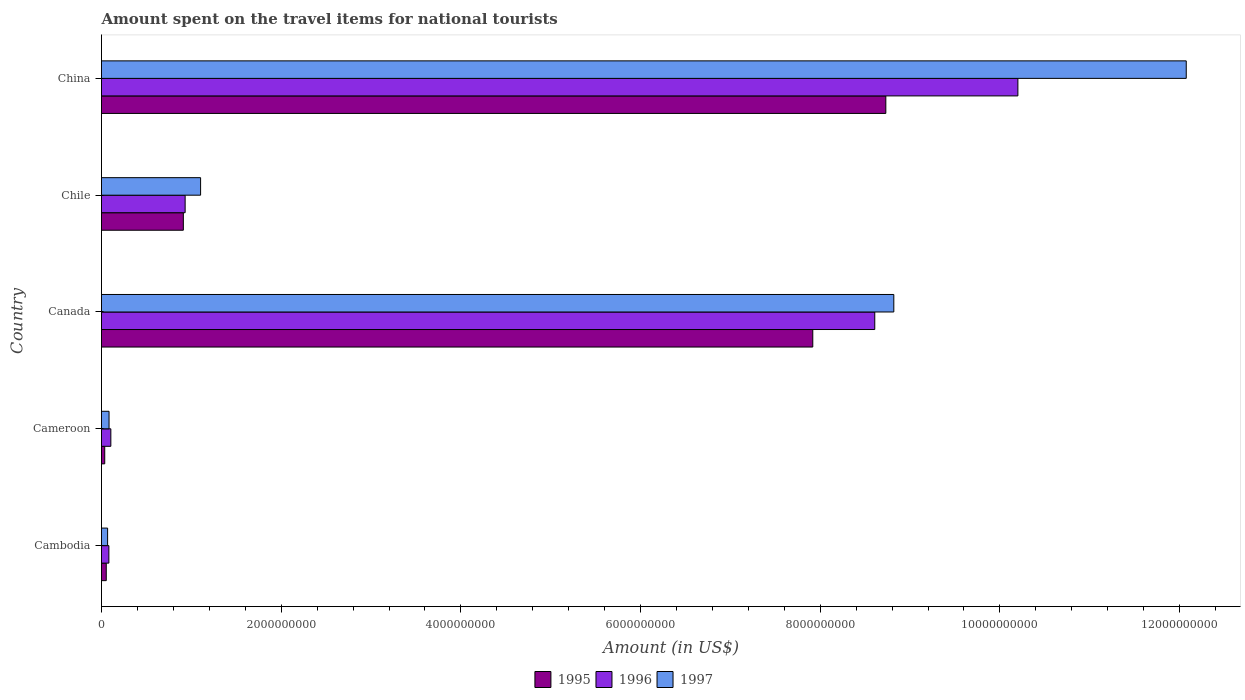How many different coloured bars are there?
Keep it short and to the point. 3. Are the number of bars per tick equal to the number of legend labels?
Make the answer very short. Yes. Are the number of bars on each tick of the Y-axis equal?
Provide a succinct answer. Yes. What is the label of the 3rd group of bars from the top?
Offer a terse response. Canada. What is the amount spent on the travel items for national tourists in 1997 in Cameroon?
Your answer should be very brief. 8.40e+07. Across all countries, what is the maximum amount spent on the travel items for national tourists in 1997?
Your answer should be very brief. 1.21e+1. Across all countries, what is the minimum amount spent on the travel items for national tourists in 1995?
Offer a terse response. 3.60e+07. In which country was the amount spent on the travel items for national tourists in 1996 maximum?
Keep it short and to the point. China. In which country was the amount spent on the travel items for national tourists in 1997 minimum?
Make the answer very short. Cambodia. What is the total amount spent on the travel items for national tourists in 1996 in the graph?
Keep it short and to the point. 1.99e+1. What is the difference between the amount spent on the travel items for national tourists in 1997 in Cambodia and that in Cameroon?
Your answer should be compact. -1.60e+07. What is the difference between the amount spent on the travel items for national tourists in 1996 in Chile and the amount spent on the travel items for national tourists in 1995 in Cambodia?
Your response must be concise. 8.78e+08. What is the average amount spent on the travel items for national tourists in 1995 per country?
Offer a very short reply. 3.53e+09. What is the difference between the amount spent on the travel items for national tourists in 1997 and amount spent on the travel items for national tourists in 1996 in Cameroon?
Your answer should be very brief. -2.00e+07. What is the ratio of the amount spent on the travel items for national tourists in 1997 in Canada to that in China?
Offer a very short reply. 0.73. Is the amount spent on the travel items for national tourists in 1996 in Cameroon less than that in Canada?
Offer a terse response. Yes. Is the difference between the amount spent on the travel items for national tourists in 1997 in Canada and Chile greater than the difference between the amount spent on the travel items for national tourists in 1996 in Canada and Chile?
Give a very brief answer. Yes. What is the difference between the highest and the second highest amount spent on the travel items for national tourists in 1995?
Offer a terse response. 8.13e+08. What is the difference between the highest and the lowest amount spent on the travel items for national tourists in 1995?
Ensure brevity in your answer.  8.69e+09. Is the sum of the amount spent on the travel items for national tourists in 1997 in Chile and China greater than the maximum amount spent on the travel items for national tourists in 1995 across all countries?
Your answer should be very brief. Yes. What does the 2nd bar from the top in China represents?
Keep it short and to the point. 1996. What does the 1st bar from the bottom in Cambodia represents?
Provide a succinct answer. 1995. How many bars are there?
Provide a succinct answer. 15. Are all the bars in the graph horizontal?
Make the answer very short. Yes. How many countries are there in the graph?
Give a very brief answer. 5. Does the graph contain any zero values?
Offer a terse response. No. Does the graph contain grids?
Ensure brevity in your answer.  No. How many legend labels are there?
Ensure brevity in your answer.  3. What is the title of the graph?
Your response must be concise. Amount spent on the travel items for national tourists. What is the Amount (in US$) of 1995 in Cambodia?
Keep it short and to the point. 5.30e+07. What is the Amount (in US$) in 1996 in Cambodia?
Offer a terse response. 8.20e+07. What is the Amount (in US$) of 1997 in Cambodia?
Your response must be concise. 6.80e+07. What is the Amount (in US$) of 1995 in Cameroon?
Your answer should be compact. 3.60e+07. What is the Amount (in US$) in 1996 in Cameroon?
Provide a short and direct response. 1.04e+08. What is the Amount (in US$) in 1997 in Cameroon?
Keep it short and to the point. 8.40e+07. What is the Amount (in US$) in 1995 in Canada?
Your answer should be very brief. 7.92e+09. What is the Amount (in US$) of 1996 in Canada?
Offer a very short reply. 8.61e+09. What is the Amount (in US$) in 1997 in Canada?
Offer a terse response. 8.82e+09. What is the Amount (in US$) of 1995 in Chile?
Your answer should be compact. 9.11e+08. What is the Amount (in US$) in 1996 in Chile?
Offer a very short reply. 9.31e+08. What is the Amount (in US$) of 1997 in Chile?
Your answer should be very brief. 1.10e+09. What is the Amount (in US$) in 1995 in China?
Offer a terse response. 8.73e+09. What is the Amount (in US$) in 1996 in China?
Your answer should be compact. 1.02e+1. What is the Amount (in US$) in 1997 in China?
Ensure brevity in your answer.  1.21e+1. Across all countries, what is the maximum Amount (in US$) of 1995?
Offer a terse response. 8.73e+09. Across all countries, what is the maximum Amount (in US$) of 1996?
Ensure brevity in your answer.  1.02e+1. Across all countries, what is the maximum Amount (in US$) in 1997?
Your answer should be compact. 1.21e+1. Across all countries, what is the minimum Amount (in US$) of 1995?
Your answer should be very brief. 3.60e+07. Across all countries, what is the minimum Amount (in US$) in 1996?
Keep it short and to the point. 8.20e+07. Across all countries, what is the minimum Amount (in US$) in 1997?
Provide a succinct answer. 6.80e+07. What is the total Amount (in US$) of 1995 in the graph?
Give a very brief answer. 1.76e+1. What is the total Amount (in US$) of 1996 in the graph?
Provide a short and direct response. 1.99e+1. What is the total Amount (in US$) in 1997 in the graph?
Make the answer very short. 2.21e+1. What is the difference between the Amount (in US$) in 1995 in Cambodia and that in Cameroon?
Your answer should be very brief. 1.70e+07. What is the difference between the Amount (in US$) of 1996 in Cambodia and that in Cameroon?
Make the answer very short. -2.20e+07. What is the difference between the Amount (in US$) in 1997 in Cambodia and that in Cameroon?
Offer a very short reply. -1.60e+07. What is the difference between the Amount (in US$) in 1995 in Cambodia and that in Canada?
Provide a short and direct response. -7.86e+09. What is the difference between the Amount (in US$) of 1996 in Cambodia and that in Canada?
Offer a terse response. -8.52e+09. What is the difference between the Amount (in US$) of 1997 in Cambodia and that in Canada?
Provide a succinct answer. -8.75e+09. What is the difference between the Amount (in US$) of 1995 in Cambodia and that in Chile?
Ensure brevity in your answer.  -8.58e+08. What is the difference between the Amount (in US$) of 1996 in Cambodia and that in Chile?
Offer a terse response. -8.49e+08. What is the difference between the Amount (in US$) in 1997 in Cambodia and that in Chile?
Offer a terse response. -1.04e+09. What is the difference between the Amount (in US$) of 1995 in Cambodia and that in China?
Offer a very short reply. -8.68e+09. What is the difference between the Amount (in US$) of 1996 in Cambodia and that in China?
Offer a very short reply. -1.01e+1. What is the difference between the Amount (in US$) in 1997 in Cambodia and that in China?
Provide a succinct answer. -1.20e+1. What is the difference between the Amount (in US$) in 1995 in Cameroon and that in Canada?
Keep it short and to the point. -7.88e+09. What is the difference between the Amount (in US$) in 1996 in Cameroon and that in Canada?
Offer a terse response. -8.50e+09. What is the difference between the Amount (in US$) in 1997 in Cameroon and that in Canada?
Your answer should be very brief. -8.74e+09. What is the difference between the Amount (in US$) of 1995 in Cameroon and that in Chile?
Keep it short and to the point. -8.75e+08. What is the difference between the Amount (in US$) in 1996 in Cameroon and that in Chile?
Your response must be concise. -8.27e+08. What is the difference between the Amount (in US$) in 1997 in Cameroon and that in Chile?
Ensure brevity in your answer.  -1.02e+09. What is the difference between the Amount (in US$) of 1995 in Cameroon and that in China?
Your response must be concise. -8.69e+09. What is the difference between the Amount (in US$) of 1996 in Cameroon and that in China?
Ensure brevity in your answer.  -1.01e+1. What is the difference between the Amount (in US$) of 1997 in Cameroon and that in China?
Make the answer very short. -1.20e+1. What is the difference between the Amount (in US$) of 1995 in Canada and that in Chile?
Provide a succinct answer. 7.01e+09. What is the difference between the Amount (in US$) of 1996 in Canada and that in Chile?
Provide a short and direct response. 7.68e+09. What is the difference between the Amount (in US$) of 1997 in Canada and that in Chile?
Provide a succinct answer. 7.72e+09. What is the difference between the Amount (in US$) in 1995 in Canada and that in China?
Give a very brief answer. -8.13e+08. What is the difference between the Amount (in US$) of 1996 in Canada and that in China?
Your answer should be very brief. -1.59e+09. What is the difference between the Amount (in US$) in 1997 in Canada and that in China?
Ensure brevity in your answer.  -3.26e+09. What is the difference between the Amount (in US$) in 1995 in Chile and that in China?
Keep it short and to the point. -7.82e+09. What is the difference between the Amount (in US$) in 1996 in Chile and that in China?
Provide a succinct answer. -9.27e+09. What is the difference between the Amount (in US$) in 1997 in Chile and that in China?
Keep it short and to the point. -1.10e+1. What is the difference between the Amount (in US$) in 1995 in Cambodia and the Amount (in US$) in 1996 in Cameroon?
Provide a short and direct response. -5.10e+07. What is the difference between the Amount (in US$) in 1995 in Cambodia and the Amount (in US$) in 1997 in Cameroon?
Offer a very short reply. -3.10e+07. What is the difference between the Amount (in US$) in 1995 in Cambodia and the Amount (in US$) in 1996 in Canada?
Provide a succinct answer. -8.55e+09. What is the difference between the Amount (in US$) in 1995 in Cambodia and the Amount (in US$) in 1997 in Canada?
Your answer should be very brief. -8.77e+09. What is the difference between the Amount (in US$) in 1996 in Cambodia and the Amount (in US$) in 1997 in Canada?
Your answer should be very brief. -8.74e+09. What is the difference between the Amount (in US$) in 1995 in Cambodia and the Amount (in US$) in 1996 in Chile?
Provide a short and direct response. -8.78e+08. What is the difference between the Amount (in US$) in 1995 in Cambodia and the Amount (in US$) in 1997 in Chile?
Your response must be concise. -1.05e+09. What is the difference between the Amount (in US$) of 1996 in Cambodia and the Amount (in US$) of 1997 in Chile?
Make the answer very short. -1.02e+09. What is the difference between the Amount (in US$) in 1995 in Cambodia and the Amount (in US$) in 1996 in China?
Offer a terse response. -1.01e+1. What is the difference between the Amount (in US$) in 1995 in Cambodia and the Amount (in US$) in 1997 in China?
Give a very brief answer. -1.20e+1. What is the difference between the Amount (in US$) in 1996 in Cambodia and the Amount (in US$) in 1997 in China?
Give a very brief answer. -1.20e+1. What is the difference between the Amount (in US$) of 1995 in Cameroon and the Amount (in US$) of 1996 in Canada?
Your response must be concise. -8.57e+09. What is the difference between the Amount (in US$) in 1995 in Cameroon and the Amount (in US$) in 1997 in Canada?
Offer a terse response. -8.78e+09. What is the difference between the Amount (in US$) of 1996 in Cameroon and the Amount (in US$) of 1997 in Canada?
Provide a short and direct response. -8.72e+09. What is the difference between the Amount (in US$) of 1995 in Cameroon and the Amount (in US$) of 1996 in Chile?
Give a very brief answer. -8.95e+08. What is the difference between the Amount (in US$) of 1995 in Cameroon and the Amount (in US$) of 1997 in Chile?
Ensure brevity in your answer.  -1.07e+09. What is the difference between the Amount (in US$) in 1996 in Cameroon and the Amount (in US$) in 1997 in Chile?
Make the answer very short. -9.99e+08. What is the difference between the Amount (in US$) of 1995 in Cameroon and the Amount (in US$) of 1996 in China?
Give a very brief answer. -1.02e+1. What is the difference between the Amount (in US$) in 1995 in Cameroon and the Amount (in US$) in 1997 in China?
Your response must be concise. -1.20e+1. What is the difference between the Amount (in US$) of 1996 in Cameroon and the Amount (in US$) of 1997 in China?
Your answer should be compact. -1.20e+1. What is the difference between the Amount (in US$) in 1995 in Canada and the Amount (in US$) in 1996 in Chile?
Provide a succinct answer. 6.99e+09. What is the difference between the Amount (in US$) of 1995 in Canada and the Amount (in US$) of 1997 in Chile?
Give a very brief answer. 6.81e+09. What is the difference between the Amount (in US$) in 1996 in Canada and the Amount (in US$) in 1997 in Chile?
Keep it short and to the point. 7.50e+09. What is the difference between the Amount (in US$) of 1995 in Canada and the Amount (in US$) of 1996 in China?
Your answer should be very brief. -2.28e+09. What is the difference between the Amount (in US$) in 1995 in Canada and the Amount (in US$) in 1997 in China?
Give a very brief answer. -4.16e+09. What is the difference between the Amount (in US$) in 1996 in Canada and the Amount (in US$) in 1997 in China?
Provide a succinct answer. -3.47e+09. What is the difference between the Amount (in US$) of 1995 in Chile and the Amount (in US$) of 1996 in China?
Offer a terse response. -9.29e+09. What is the difference between the Amount (in US$) in 1995 in Chile and the Amount (in US$) in 1997 in China?
Make the answer very short. -1.12e+1. What is the difference between the Amount (in US$) of 1996 in Chile and the Amount (in US$) of 1997 in China?
Your answer should be compact. -1.11e+1. What is the average Amount (in US$) of 1995 per country?
Keep it short and to the point. 3.53e+09. What is the average Amount (in US$) of 1996 per country?
Ensure brevity in your answer.  3.98e+09. What is the average Amount (in US$) in 1997 per country?
Give a very brief answer. 4.43e+09. What is the difference between the Amount (in US$) in 1995 and Amount (in US$) in 1996 in Cambodia?
Provide a succinct answer. -2.90e+07. What is the difference between the Amount (in US$) in 1995 and Amount (in US$) in 1997 in Cambodia?
Provide a succinct answer. -1.50e+07. What is the difference between the Amount (in US$) in 1996 and Amount (in US$) in 1997 in Cambodia?
Ensure brevity in your answer.  1.40e+07. What is the difference between the Amount (in US$) of 1995 and Amount (in US$) of 1996 in Cameroon?
Give a very brief answer. -6.80e+07. What is the difference between the Amount (in US$) in 1995 and Amount (in US$) in 1997 in Cameroon?
Offer a very short reply. -4.80e+07. What is the difference between the Amount (in US$) of 1995 and Amount (in US$) of 1996 in Canada?
Keep it short and to the point. -6.90e+08. What is the difference between the Amount (in US$) in 1995 and Amount (in US$) in 1997 in Canada?
Ensure brevity in your answer.  -9.02e+08. What is the difference between the Amount (in US$) of 1996 and Amount (in US$) of 1997 in Canada?
Ensure brevity in your answer.  -2.12e+08. What is the difference between the Amount (in US$) in 1995 and Amount (in US$) in 1996 in Chile?
Ensure brevity in your answer.  -2.00e+07. What is the difference between the Amount (in US$) in 1995 and Amount (in US$) in 1997 in Chile?
Ensure brevity in your answer.  -1.92e+08. What is the difference between the Amount (in US$) in 1996 and Amount (in US$) in 1997 in Chile?
Provide a short and direct response. -1.72e+08. What is the difference between the Amount (in US$) of 1995 and Amount (in US$) of 1996 in China?
Your response must be concise. -1.47e+09. What is the difference between the Amount (in US$) of 1995 and Amount (in US$) of 1997 in China?
Make the answer very short. -3.34e+09. What is the difference between the Amount (in US$) of 1996 and Amount (in US$) of 1997 in China?
Your answer should be compact. -1.87e+09. What is the ratio of the Amount (in US$) in 1995 in Cambodia to that in Cameroon?
Your answer should be very brief. 1.47. What is the ratio of the Amount (in US$) of 1996 in Cambodia to that in Cameroon?
Your response must be concise. 0.79. What is the ratio of the Amount (in US$) in 1997 in Cambodia to that in Cameroon?
Your answer should be compact. 0.81. What is the ratio of the Amount (in US$) in 1995 in Cambodia to that in Canada?
Give a very brief answer. 0.01. What is the ratio of the Amount (in US$) of 1996 in Cambodia to that in Canada?
Give a very brief answer. 0.01. What is the ratio of the Amount (in US$) of 1997 in Cambodia to that in Canada?
Offer a very short reply. 0.01. What is the ratio of the Amount (in US$) in 1995 in Cambodia to that in Chile?
Your answer should be compact. 0.06. What is the ratio of the Amount (in US$) in 1996 in Cambodia to that in Chile?
Your response must be concise. 0.09. What is the ratio of the Amount (in US$) of 1997 in Cambodia to that in Chile?
Make the answer very short. 0.06. What is the ratio of the Amount (in US$) in 1995 in Cambodia to that in China?
Your response must be concise. 0.01. What is the ratio of the Amount (in US$) of 1996 in Cambodia to that in China?
Offer a very short reply. 0.01. What is the ratio of the Amount (in US$) in 1997 in Cambodia to that in China?
Keep it short and to the point. 0.01. What is the ratio of the Amount (in US$) of 1995 in Cameroon to that in Canada?
Your answer should be very brief. 0. What is the ratio of the Amount (in US$) in 1996 in Cameroon to that in Canada?
Your response must be concise. 0.01. What is the ratio of the Amount (in US$) of 1997 in Cameroon to that in Canada?
Offer a very short reply. 0.01. What is the ratio of the Amount (in US$) in 1995 in Cameroon to that in Chile?
Your answer should be compact. 0.04. What is the ratio of the Amount (in US$) in 1996 in Cameroon to that in Chile?
Ensure brevity in your answer.  0.11. What is the ratio of the Amount (in US$) in 1997 in Cameroon to that in Chile?
Your answer should be very brief. 0.08. What is the ratio of the Amount (in US$) in 1995 in Cameroon to that in China?
Provide a succinct answer. 0. What is the ratio of the Amount (in US$) of 1996 in Cameroon to that in China?
Provide a short and direct response. 0.01. What is the ratio of the Amount (in US$) of 1997 in Cameroon to that in China?
Give a very brief answer. 0.01. What is the ratio of the Amount (in US$) in 1995 in Canada to that in Chile?
Provide a succinct answer. 8.69. What is the ratio of the Amount (in US$) of 1996 in Canada to that in Chile?
Offer a very short reply. 9.24. What is the ratio of the Amount (in US$) of 1997 in Canada to that in Chile?
Your answer should be very brief. 8. What is the ratio of the Amount (in US$) of 1995 in Canada to that in China?
Your answer should be very brief. 0.91. What is the ratio of the Amount (in US$) of 1996 in Canada to that in China?
Offer a terse response. 0.84. What is the ratio of the Amount (in US$) of 1997 in Canada to that in China?
Ensure brevity in your answer.  0.73. What is the ratio of the Amount (in US$) in 1995 in Chile to that in China?
Ensure brevity in your answer.  0.1. What is the ratio of the Amount (in US$) in 1996 in Chile to that in China?
Your response must be concise. 0.09. What is the ratio of the Amount (in US$) of 1997 in Chile to that in China?
Your response must be concise. 0.09. What is the difference between the highest and the second highest Amount (in US$) in 1995?
Provide a short and direct response. 8.13e+08. What is the difference between the highest and the second highest Amount (in US$) in 1996?
Your answer should be very brief. 1.59e+09. What is the difference between the highest and the second highest Amount (in US$) in 1997?
Provide a succinct answer. 3.26e+09. What is the difference between the highest and the lowest Amount (in US$) of 1995?
Make the answer very short. 8.69e+09. What is the difference between the highest and the lowest Amount (in US$) of 1996?
Make the answer very short. 1.01e+1. What is the difference between the highest and the lowest Amount (in US$) in 1997?
Your answer should be very brief. 1.20e+1. 